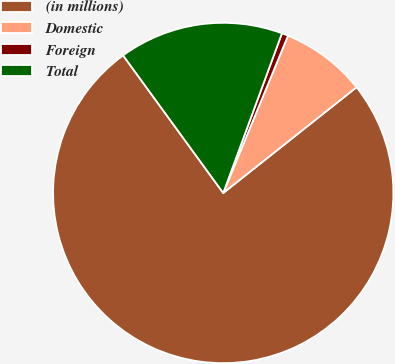Convert chart. <chart><loc_0><loc_0><loc_500><loc_500><pie_chart><fcel>(in millions)<fcel>Domestic<fcel>Foreign<fcel>Total<nl><fcel>75.67%<fcel>8.11%<fcel>0.61%<fcel>15.62%<nl></chart> 